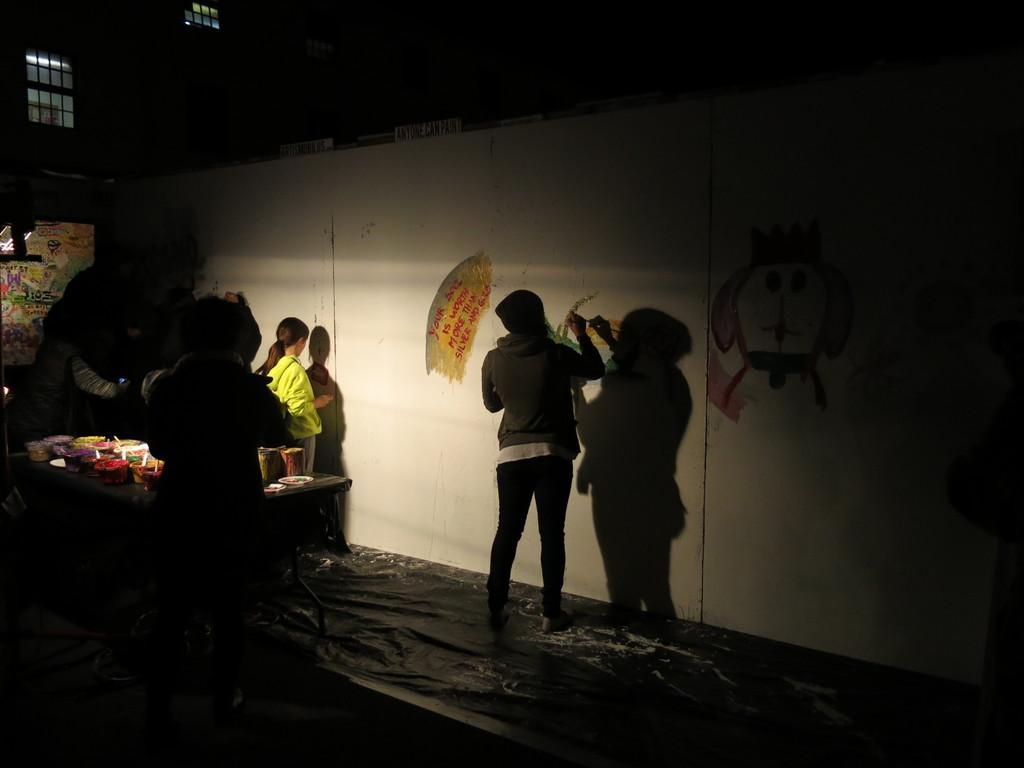How many people are in the image? There are people in the image. What is the background of the image? There is a wall in the image. Are there any openings in the wall? Yes, there are windows in the image. What is present in the room? There is a table in the image. What is on the table? Objects are present on the table. What is one person doing in the image? One person is painting on the wall. Can you see any farmers in the image? There is no mention of a farmer in the image. Is there any quicksand present in the image? There is no quicksand present in the image. 